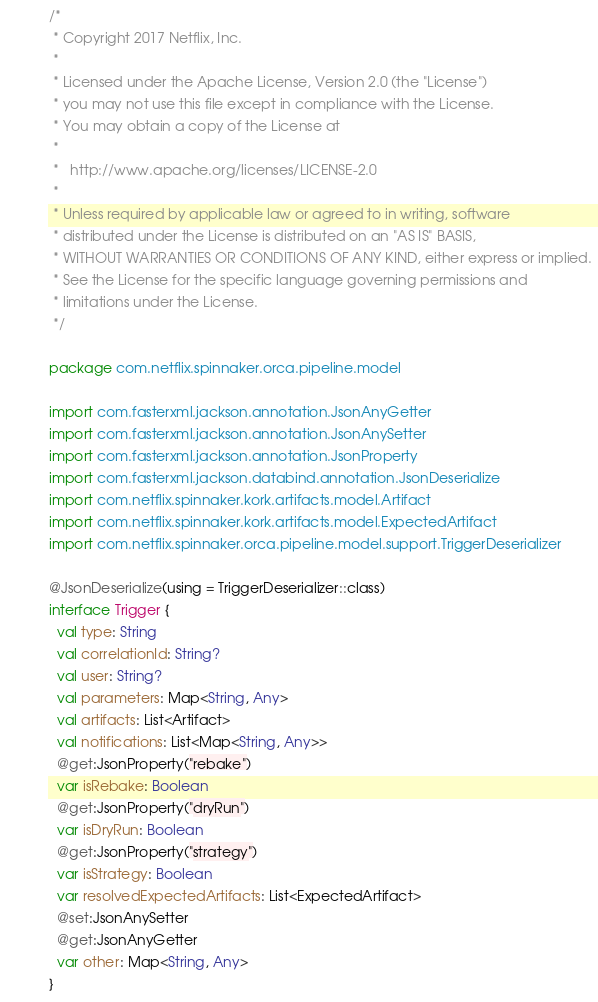Convert code to text. <code><loc_0><loc_0><loc_500><loc_500><_Kotlin_>/*
 * Copyright 2017 Netflix, Inc.
 *
 * Licensed under the Apache License, Version 2.0 (the "License")
 * you may not use this file except in compliance with the License.
 * You may obtain a copy of the License at
 *
 *   http://www.apache.org/licenses/LICENSE-2.0
 *
 * Unless required by applicable law or agreed to in writing, software
 * distributed under the License is distributed on an "AS IS" BASIS,
 * WITHOUT WARRANTIES OR CONDITIONS OF ANY KIND, either express or implied.
 * See the License for the specific language governing permissions and
 * limitations under the License.
 */

package com.netflix.spinnaker.orca.pipeline.model

import com.fasterxml.jackson.annotation.JsonAnyGetter
import com.fasterxml.jackson.annotation.JsonAnySetter
import com.fasterxml.jackson.annotation.JsonProperty
import com.fasterxml.jackson.databind.annotation.JsonDeserialize
import com.netflix.spinnaker.kork.artifacts.model.Artifact
import com.netflix.spinnaker.kork.artifacts.model.ExpectedArtifact
import com.netflix.spinnaker.orca.pipeline.model.support.TriggerDeserializer

@JsonDeserialize(using = TriggerDeserializer::class)
interface Trigger {
  val type: String
  val correlationId: String?
  val user: String?
  val parameters: Map<String, Any>
  val artifacts: List<Artifact>
  val notifications: List<Map<String, Any>>
  @get:JsonProperty("rebake")
  var isRebake: Boolean
  @get:JsonProperty("dryRun")
  var isDryRun: Boolean
  @get:JsonProperty("strategy")
  var isStrategy: Boolean
  var resolvedExpectedArtifacts: List<ExpectedArtifact>
  @set:JsonAnySetter
  @get:JsonAnyGetter
  var other: Map<String, Any>
}
</code> 